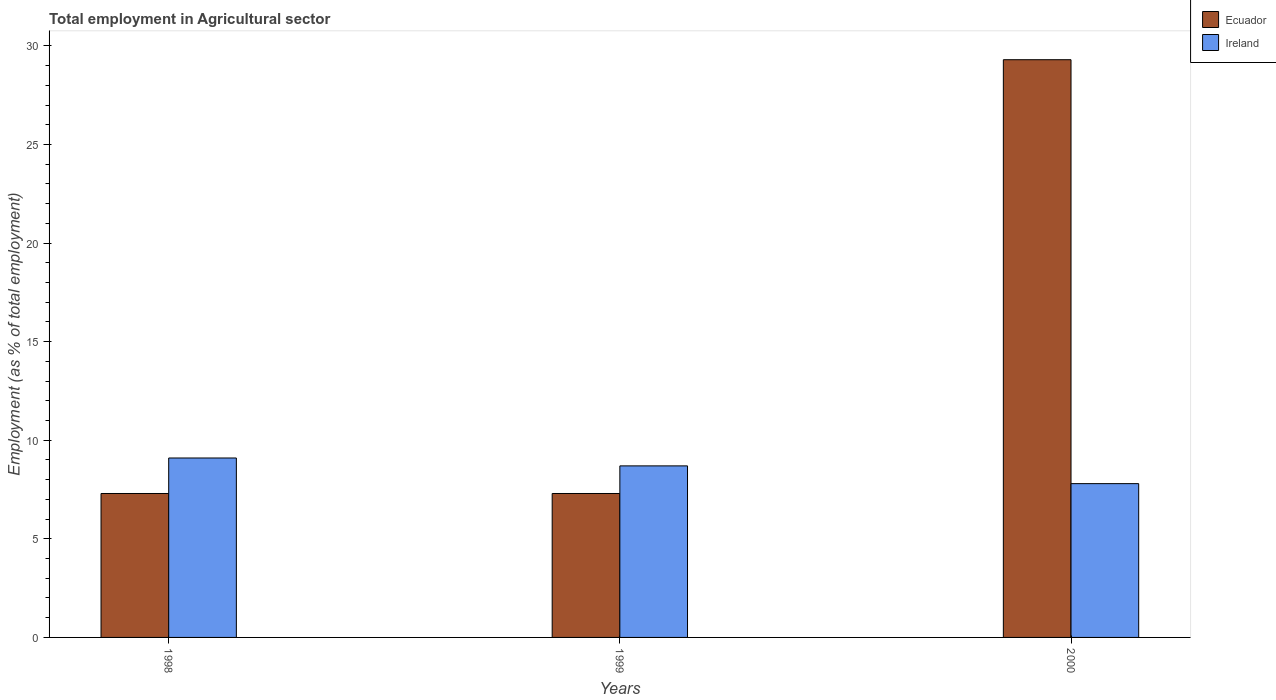How many different coloured bars are there?
Offer a very short reply. 2. Are the number of bars per tick equal to the number of legend labels?
Your response must be concise. Yes. Are the number of bars on each tick of the X-axis equal?
Offer a terse response. Yes. What is the label of the 2nd group of bars from the left?
Offer a terse response. 1999. In how many cases, is the number of bars for a given year not equal to the number of legend labels?
Make the answer very short. 0. What is the employment in agricultural sector in Ireland in 1998?
Keep it short and to the point. 9.1. Across all years, what is the maximum employment in agricultural sector in Ecuador?
Your response must be concise. 29.3. Across all years, what is the minimum employment in agricultural sector in Ecuador?
Your answer should be compact. 7.3. In which year was the employment in agricultural sector in Ireland maximum?
Keep it short and to the point. 1998. In which year was the employment in agricultural sector in Ecuador minimum?
Provide a succinct answer. 1998. What is the total employment in agricultural sector in Ecuador in the graph?
Provide a succinct answer. 43.9. What is the difference between the employment in agricultural sector in Ecuador in 1999 and that in 2000?
Give a very brief answer. -22. What is the difference between the employment in agricultural sector in Ireland in 1998 and the employment in agricultural sector in Ecuador in 1999?
Ensure brevity in your answer.  1.8. What is the average employment in agricultural sector in Ecuador per year?
Provide a short and direct response. 14.63. In the year 2000, what is the difference between the employment in agricultural sector in Ireland and employment in agricultural sector in Ecuador?
Provide a succinct answer. -21.5. What is the ratio of the employment in agricultural sector in Ireland in 1999 to that in 2000?
Your response must be concise. 1.12. Is the employment in agricultural sector in Ireland in 1999 less than that in 2000?
Provide a short and direct response. No. Is the difference between the employment in agricultural sector in Ireland in 1999 and 2000 greater than the difference between the employment in agricultural sector in Ecuador in 1999 and 2000?
Your answer should be compact. Yes. What is the difference between the highest and the second highest employment in agricultural sector in Ecuador?
Make the answer very short. 22. What is the difference between the highest and the lowest employment in agricultural sector in Ireland?
Your answer should be very brief. 1.3. What does the 1st bar from the left in 2000 represents?
Ensure brevity in your answer.  Ecuador. What does the 2nd bar from the right in 1998 represents?
Give a very brief answer. Ecuador. How many bars are there?
Provide a short and direct response. 6. How many years are there in the graph?
Provide a short and direct response. 3. What is the difference between two consecutive major ticks on the Y-axis?
Provide a succinct answer. 5. Does the graph contain grids?
Offer a very short reply. No. How are the legend labels stacked?
Give a very brief answer. Vertical. What is the title of the graph?
Your answer should be compact. Total employment in Agricultural sector. What is the label or title of the X-axis?
Ensure brevity in your answer.  Years. What is the label or title of the Y-axis?
Make the answer very short. Employment (as % of total employment). What is the Employment (as % of total employment) in Ecuador in 1998?
Provide a succinct answer. 7.3. What is the Employment (as % of total employment) of Ireland in 1998?
Give a very brief answer. 9.1. What is the Employment (as % of total employment) of Ecuador in 1999?
Your answer should be compact. 7.3. What is the Employment (as % of total employment) of Ireland in 1999?
Keep it short and to the point. 8.7. What is the Employment (as % of total employment) of Ecuador in 2000?
Your answer should be very brief. 29.3. What is the Employment (as % of total employment) in Ireland in 2000?
Keep it short and to the point. 7.8. Across all years, what is the maximum Employment (as % of total employment) of Ecuador?
Provide a short and direct response. 29.3. Across all years, what is the maximum Employment (as % of total employment) of Ireland?
Offer a terse response. 9.1. Across all years, what is the minimum Employment (as % of total employment) of Ecuador?
Offer a terse response. 7.3. Across all years, what is the minimum Employment (as % of total employment) of Ireland?
Give a very brief answer. 7.8. What is the total Employment (as % of total employment) in Ecuador in the graph?
Ensure brevity in your answer.  43.9. What is the total Employment (as % of total employment) in Ireland in the graph?
Offer a very short reply. 25.6. What is the difference between the Employment (as % of total employment) of Ecuador in 1998 and that in 1999?
Your answer should be compact. 0. What is the difference between the Employment (as % of total employment) of Ecuador in 1998 and that in 2000?
Ensure brevity in your answer.  -22. What is the difference between the Employment (as % of total employment) of Ireland in 1998 and that in 2000?
Keep it short and to the point. 1.3. What is the difference between the Employment (as % of total employment) of Ireland in 1999 and that in 2000?
Give a very brief answer. 0.9. What is the difference between the Employment (as % of total employment) of Ecuador in 1998 and the Employment (as % of total employment) of Ireland in 1999?
Your response must be concise. -1.4. What is the difference between the Employment (as % of total employment) in Ecuador in 1998 and the Employment (as % of total employment) in Ireland in 2000?
Your answer should be very brief. -0.5. What is the average Employment (as % of total employment) in Ecuador per year?
Give a very brief answer. 14.63. What is the average Employment (as % of total employment) of Ireland per year?
Provide a succinct answer. 8.53. In the year 1998, what is the difference between the Employment (as % of total employment) of Ecuador and Employment (as % of total employment) of Ireland?
Your answer should be compact. -1.8. What is the ratio of the Employment (as % of total employment) of Ireland in 1998 to that in 1999?
Your answer should be compact. 1.05. What is the ratio of the Employment (as % of total employment) of Ecuador in 1998 to that in 2000?
Your answer should be compact. 0.25. What is the ratio of the Employment (as % of total employment) in Ireland in 1998 to that in 2000?
Keep it short and to the point. 1.17. What is the ratio of the Employment (as % of total employment) of Ecuador in 1999 to that in 2000?
Provide a short and direct response. 0.25. What is the ratio of the Employment (as % of total employment) in Ireland in 1999 to that in 2000?
Offer a very short reply. 1.12. What is the difference between the highest and the second highest Employment (as % of total employment) in Ecuador?
Provide a succinct answer. 22. What is the difference between the highest and the second highest Employment (as % of total employment) of Ireland?
Make the answer very short. 0.4. What is the difference between the highest and the lowest Employment (as % of total employment) of Ireland?
Keep it short and to the point. 1.3. 